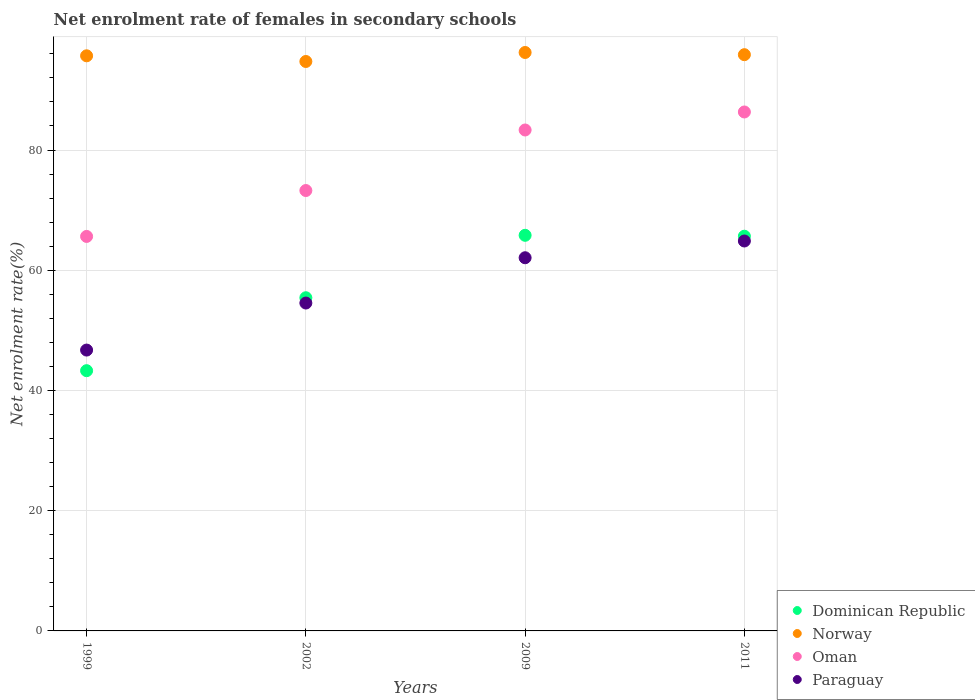How many different coloured dotlines are there?
Offer a terse response. 4. Is the number of dotlines equal to the number of legend labels?
Keep it short and to the point. Yes. What is the net enrolment rate of females in secondary schools in Dominican Republic in 2009?
Your answer should be very brief. 65.81. Across all years, what is the maximum net enrolment rate of females in secondary schools in Norway?
Keep it short and to the point. 96.23. Across all years, what is the minimum net enrolment rate of females in secondary schools in Paraguay?
Offer a very short reply. 46.72. In which year was the net enrolment rate of females in secondary schools in Paraguay maximum?
Make the answer very short. 2011. What is the total net enrolment rate of females in secondary schools in Dominican Republic in the graph?
Keep it short and to the point. 230.2. What is the difference between the net enrolment rate of females in secondary schools in Norway in 1999 and that in 2011?
Your answer should be compact. -0.19. What is the difference between the net enrolment rate of females in secondary schools in Oman in 1999 and the net enrolment rate of females in secondary schools in Paraguay in 2009?
Make the answer very short. 3.55. What is the average net enrolment rate of females in secondary schools in Paraguay per year?
Your response must be concise. 57.05. In the year 2002, what is the difference between the net enrolment rate of females in secondary schools in Dominican Republic and net enrolment rate of females in secondary schools in Paraguay?
Your response must be concise. 0.88. In how many years, is the net enrolment rate of females in secondary schools in Paraguay greater than 16 %?
Provide a succinct answer. 4. What is the ratio of the net enrolment rate of females in secondary schools in Paraguay in 1999 to that in 2002?
Give a very brief answer. 0.86. Is the net enrolment rate of females in secondary schools in Dominican Republic in 1999 less than that in 2011?
Your response must be concise. Yes. What is the difference between the highest and the second highest net enrolment rate of females in secondary schools in Paraguay?
Give a very brief answer. 2.79. What is the difference between the highest and the lowest net enrolment rate of females in secondary schools in Dominican Republic?
Offer a very short reply. 22.52. In how many years, is the net enrolment rate of females in secondary schools in Dominican Republic greater than the average net enrolment rate of females in secondary schools in Dominican Republic taken over all years?
Provide a short and direct response. 2. Is it the case that in every year, the sum of the net enrolment rate of females in secondary schools in Oman and net enrolment rate of females in secondary schools in Paraguay  is greater than the net enrolment rate of females in secondary schools in Dominican Republic?
Your answer should be compact. Yes. Does the net enrolment rate of females in secondary schools in Oman monotonically increase over the years?
Make the answer very short. Yes. Is the net enrolment rate of females in secondary schools in Oman strictly greater than the net enrolment rate of females in secondary schools in Norway over the years?
Ensure brevity in your answer.  No. How many dotlines are there?
Give a very brief answer. 4. How many years are there in the graph?
Offer a terse response. 4. What is the difference between two consecutive major ticks on the Y-axis?
Your answer should be compact. 20. Where does the legend appear in the graph?
Ensure brevity in your answer.  Bottom right. What is the title of the graph?
Make the answer very short. Net enrolment rate of females in secondary schools. What is the label or title of the Y-axis?
Offer a very short reply. Net enrolment rate(%). What is the Net enrolment rate(%) of Dominican Republic in 1999?
Offer a terse response. 43.29. What is the Net enrolment rate(%) of Norway in 1999?
Your answer should be very brief. 95.68. What is the Net enrolment rate(%) in Oman in 1999?
Provide a succinct answer. 65.63. What is the Net enrolment rate(%) in Paraguay in 1999?
Keep it short and to the point. 46.72. What is the Net enrolment rate(%) in Dominican Republic in 2002?
Your answer should be very brief. 55.43. What is the Net enrolment rate(%) of Norway in 2002?
Your answer should be very brief. 94.73. What is the Net enrolment rate(%) of Oman in 2002?
Your answer should be very brief. 73.26. What is the Net enrolment rate(%) in Paraguay in 2002?
Provide a short and direct response. 54.55. What is the Net enrolment rate(%) of Dominican Republic in 2009?
Your response must be concise. 65.81. What is the Net enrolment rate(%) in Norway in 2009?
Provide a short and direct response. 96.23. What is the Net enrolment rate(%) of Oman in 2009?
Your response must be concise. 83.33. What is the Net enrolment rate(%) in Paraguay in 2009?
Your response must be concise. 62.08. What is the Net enrolment rate(%) in Dominican Republic in 2011?
Offer a very short reply. 65.66. What is the Net enrolment rate(%) in Norway in 2011?
Offer a terse response. 95.86. What is the Net enrolment rate(%) in Oman in 2011?
Ensure brevity in your answer.  86.33. What is the Net enrolment rate(%) in Paraguay in 2011?
Offer a terse response. 64.87. Across all years, what is the maximum Net enrolment rate(%) of Dominican Republic?
Provide a succinct answer. 65.81. Across all years, what is the maximum Net enrolment rate(%) in Norway?
Keep it short and to the point. 96.23. Across all years, what is the maximum Net enrolment rate(%) of Oman?
Ensure brevity in your answer.  86.33. Across all years, what is the maximum Net enrolment rate(%) of Paraguay?
Offer a terse response. 64.87. Across all years, what is the minimum Net enrolment rate(%) in Dominican Republic?
Give a very brief answer. 43.29. Across all years, what is the minimum Net enrolment rate(%) of Norway?
Give a very brief answer. 94.73. Across all years, what is the minimum Net enrolment rate(%) of Oman?
Your answer should be very brief. 65.63. Across all years, what is the minimum Net enrolment rate(%) in Paraguay?
Your response must be concise. 46.72. What is the total Net enrolment rate(%) of Dominican Republic in the graph?
Make the answer very short. 230.2. What is the total Net enrolment rate(%) of Norway in the graph?
Your answer should be very brief. 382.49. What is the total Net enrolment rate(%) of Oman in the graph?
Make the answer very short. 308.55. What is the total Net enrolment rate(%) in Paraguay in the graph?
Your answer should be compact. 228.22. What is the difference between the Net enrolment rate(%) in Dominican Republic in 1999 and that in 2002?
Provide a succinct answer. -12.13. What is the difference between the Net enrolment rate(%) in Norway in 1999 and that in 2002?
Ensure brevity in your answer.  0.95. What is the difference between the Net enrolment rate(%) in Oman in 1999 and that in 2002?
Your answer should be very brief. -7.64. What is the difference between the Net enrolment rate(%) in Paraguay in 1999 and that in 2002?
Ensure brevity in your answer.  -7.82. What is the difference between the Net enrolment rate(%) of Dominican Republic in 1999 and that in 2009?
Your answer should be compact. -22.52. What is the difference between the Net enrolment rate(%) of Norway in 1999 and that in 2009?
Make the answer very short. -0.55. What is the difference between the Net enrolment rate(%) in Oman in 1999 and that in 2009?
Offer a very short reply. -17.71. What is the difference between the Net enrolment rate(%) of Paraguay in 1999 and that in 2009?
Ensure brevity in your answer.  -15.36. What is the difference between the Net enrolment rate(%) of Dominican Republic in 1999 and that in 2011?
Give a very brief answer. -22.37. What is the difference between the Net enrolment rate(%) in Norway in 1999 and that in 2011?
Ensure brevity in your answer.  -0.19. What is the difference between the Net enrolment rate(%) in Oman in 1999 and that in 2011?
Provide a short and direct response. -20.7. What is the difference between the Net enrolment rate(%) of Paraguay in 1999 and that in 2011?
Offer a very short reply. -18.15. What is the difference between the Net enrolment rate(%) in Dominican Republic in 2002 and that in 2009?
Offer a very short reply. -10.39. What is the difference between the Net enrolment rate(%) in Norway in 2002 and that in 2009?
Keep it short and to the point. -1.5. What is the difference between the Net enrolment rate(%) in Oman in 2002 and that in 2009?
Your answer should be compact. -10.07. What is the difference between the Net enrolment rate(%) in Paraguay in 2002 and that in 2009?
Offer a terse response. -7.53. What is the difference between the Net enrolment rate(%) of Dominican Republic in 2002 and that in 2011?
Offer a very short reply. -10.23. What is the difference between the Net enrolment rate(%) of Norway in 2002 and that in 2011?
Your answer should be very brief. -1.13. What is the difference between the Net enrolment rate(%) in Oman in 2002 and that in 2011?
Give a very brief answer. -13.07. What is the difference between the Net enrolment rate(%) of Paraguay in 2002 and that in 2011?
Your response must be concise. -10.32. What is the difference between the Net enrolment rate(%) of Dominican Republic in 2009 and that in 2011?
Ensure brevity in your answer.  0.15. What is the difference between the Net enrolment rate(%) in Norway in 2009 and that in 2011?
Offer a very short reply. 0.37. What is the difference between the Net enrolment rate(%) of Oman in 2009 and that in 2011?
Give a very brief answer. -3. What is the difference between the Net enrolment rate(%) in Paraguay in 2009 and that in 2011?
Your answer should be very brief. -2.79. What is the difference between the Net enrolment rate(%) in Dominican Republic in 1999 and the Net enrolment rate(%) in Norway in 2002?
Your answer should be compact. -51.44. What is the difference between the Net enrolment rate(%) in Dominican Republic in 1999 and the Net enrolment rate(%) in Oman in 2002?
Offer a terse response. -29.97. What is the difference between the Net enrolment rate(%) in Dominican Republic in 1999 and the Net enrolment rate(%) in Paraguay in 2002?
Your answer should be very brief. -11.25. What is the difference between the Net enrolment rate(%) of Norway in 1999 and the Net enrolment rate(%) of Oman in 2002?
Your answer should be very brief. 22.41. What is the difference between the Net enrolment rate(%) of Norway in 1999 and the Net enrolment rate(%) of Paraguay in 2002?
Provide a short and direct response. 41.13. What is the difference between the Net enrolment rate(%) of Oman in 1999 and the Net enrolment rate(%) of Paraguay in 2002?
Ensure brevity in your answer.  11.08. What is the difference between the Net enrolment rate(%) in Dominican Republic in 1999 and the Net enrolment rate(%) in Norway in 2009?
Give a very brief answer. -52.93. What is the difference between the Net enrolment rate(%) in Dominican Republic in 1999 and the Net enrolment rate(%) in Oman in 2009?
Provide a succinct answer. -40.04. What is the difference between the Net enrolment rate(%) of Dominican Republic in 1999 and the Net enrolment rate(%) of Paraguay in 2009?
Provide a short and direct response. -18.79. What is the difference between the Net enrolment rate(%) of Norway in 1999 and the Net enrolment rate(%) of Oman in 2009?
Ensure brevity in your answer.  12.34. What is the difference between the Net enrolment rate(%) of Norway in 1999 and the Net enrolment rate(%) of Paraguay in 2009?
Your answer should be compact. 33.6. What is the difference between the Net enrolment rate(%) in Oman in 1999 and the Net enrolment rate(%) in Paraguay in 2009?
Provide a succinct answer. 3.55. What is the difference between the Net enrolment rate(%) in Dominican Republic in 1999 and the Net enrolment rate(%) in Norway in 2011?
Make the answer very short. -52.57. What is the difference between the Net enrolment rate(%) of Dominican Republic in 1999 and the Net enrolment rate(%) of Oman in 2011?
Your answer should be compact. -43.04. What is the difference between the Net enrolment rate(%) of Dominican Republic in 1999 and the Net enrolment rate(%) of Paraguay in 2011?
Offer a terse response. -21.57. What is the difference between the Net enrolment rate(%) of Norway in 1999 and the Net enrolment rate(%) of Oman in 2011?
Make the answer very short. 9.35. What is the difference between the Net enrolment rate(%) in Norway in 1999 and the Net enrolment rate(%) in Paraguay in 2011?
Your response must be concise. 30.81. What is the difference between the Net enrolment rate(%) in Oman in 1999 and the Net enrolment rate(%) in Paraguay in 2011?
Your response must be concise. 0.76. What is the difference between the Net enrolment rate(%) of Dominican Republic in 2002 and the Net enrolment rate(%) of Norway in 2009?
Provide a succinct answer. -40.8. What is the difference between the Net enrolment rate(%) of Dominican Republic in 2002 and the Net enrolment rate(%) of Oman in 2009?
Give a very brief answer. -27.91. What is the difference between the Net enrolment rate(%) of Dominican Republic in 2002 and the Net enrolment rate(%) of Paraguay in 2009?
Offer a terse response. -6.65. What is the difference between the Net enrolment rate(%) in Norway in 2002 and the Net enrolment rate(%) in Oman in 2009?
Make the answer very short. 11.4. What is the difference between the Net enrolment rate(%) in Norway in 2002 and the Net enrolment rate(%) in Paraguay in 2009?
Your answer should be compact. 32.65. What is the difference between the Net enrolment rate(%) of Oman in 2002 and the Net enrolment rate(%) of Paraguay in 2009?
Your answer should be compact. 11.18. What is the difference between the Net enrolment rate(%) in Dominican Republic in 2002 and the Net enrolment rate(%) in Norway in 2011?
Your answer should be compact. -40.43. What is the difference between the Net enrolment rate(%) of Dominican Republic in 2002 and the Net enrolment rate(%) of Oman in 2011?
Your answer should be very brief. -30.9. What is the difference between the Net enrolment rate(%) of Dominican Republic in 2002 and the Net enrolment rate(%) of Paraguay in 2011?
Give a very brief answer. -9.44. What is the difference between the Net enrolment rate(%) of Norway in 2002 and the Net enrolment rate(%) of Oman in 2011?
Your answer should be very brief. 8.4. What is the difference between the Net enrolment rate(%) of Norway in 2002 and the Net enrolment rate(%) of Paraguay in 2011?
Provide a short and direct response. 29.86. What is the difference between the Net enrolment rate(%) in Oman in 2002 and the Net enrolment rate(%) in Paraguay in 2011?
Ensure brevity in your answer.  8.4. What is the difference between the Net enrolment rate(%) in Dominican Republic in 2009 and the Net enrolment rate(%) in Norway in 2011?
Your response must be concise. -30.05. What is the difference between the Net enrolment rate(%) in Dominican Republic in 2009 and the Net enrolment rate(%) in Oman in 2011?
Offer a very short reply. -20.52. What is the difference between the Net enrolment rate(%) in Dominican Republic in 2009 and the Net enrolment rate(%) in Paraguay in 2011?
Ensure brevity in your answer.  0.95. What is the difference between the Net enrolment rate(%) of Norway in 2009 and the Net enrolment rate(%) of Oman in 2011?
Your response must be concise. 9.9. What is the difference between the Net enrolment rate(%) of Norway in 2009 and the Net enrolment rate(%) of Paraguay in 2011?
Provide a short and direct response. 31.36. What is the difference between the Net enrolment rate(%) of Oman in 2009 and the Net enrolment rate(%) of Paraguay in 2011?
Provide a short and direct response. 18.47. What is the average Net enrolment rate(%) in Dominican Republic per year?
Offer a very short reply. 57.55. What is the average Net enrolment rate(%) in Norway per year?
Your answer should be very brief. 95.62. What is the average Net enrolment rate(%) of Oman per year?
Your answer should be compact. 77.14. What is the average Net enrolment rate(%) in Paraguay per year?
Make the answer very short. 57.05. In the year 1999, what is the difference between the Net enrolment rate(%) of Dominican Republic and Net enrolment rate(%) of Norway?
Your response must be concise. -52.38. In the year 1999, what is the difference between the Net enrolment rate(%) of Dominican Republic and Net enrolment rate(%) of Oman?
Make the answer very short. -22.33. In the year 1999, what is the difference between the Net enrolment rate(%) in Dominican Republic and Net enrolment rate(%) in Paraguay?
Your response must be concise. -3.43. In the year 1999, what is the difference between the Net enrolment rate(%) of Norway and Net enrolment rate(%) of Oman?
Offer a terse response. 30.05. In the year 1999, what is the difference between the Net enrolment rate(%) of Norway and Net enrolment rate(%) of Paraguay?
Offer a terse response. 48.95. In the year 1999, what is the difference between the Net enrolment rate(%) in Oman and Net enrolment rate(%) in Paraguay?
Offer a terse response. 18.91. In the year 2002, what is the difference between the Net enrolment rate(%) of Dominican Republic and Net enrolment rate(%) of Norway?
Your answer should be compact. -39.3. In the year 2002, what is the difference between the Net enrolment rate(%) of Dominican Republic and Net enrolment rate(%) of Oman?
Offer a very short reply. -17.84. In the year 2002, what is the difference between the Net enrolment rate(%) of Dominican Republic and Net enrolment rate(%) of Paraguay?
Offer a very short reply. 0.88. In the year 2002, what is the difference between the Net enrolment rate(%) in Norway and Net enrolment rate(%) in Oman?
Keep it short and to the point. 21.47. In the year 2002, what is the difference between the Net enrolment rate(%) of Norway and Net enrolment rate(%) of Paraguay?
Give a very brief answer. 40.18. In the year 2002, what is the difference between the Net enrolment rate(%) in Oman and Net enrolment rate(%) in Paraguay?
Make the answer very short. 18.72. In the year 2009, what is the difference between the Net enrolment rate(%) in Dominican Republic and Net enrolment rate(%) in Norway?
Provide a short and direct response. -30.41. In the year 2009, what is the difference between the Net enrolment rate(%) of Dominican Republic and Net enrolment rate(%) of Oman?
Ensure brevity in your answer.  -17.52. In the year 2009, what is the difference between the Net enrolment rate(%) in Dominican Republic and Net enrolment rate(%) in Paraguay?
Your answer should be very brief. 3.73. In the year 2009, what is the difference between the Net enrolment rate(%) of Norway and Net enrolment rate(%) of Oman?
Keep it short and to the point. 12.89. In the year 2009, what is the difference between the Net enrolment rate(%) in Norway and Net enrolment rate(%) in Paraguay?
Provide a succinct answer. 34.15. In the year 2009, what is the difference between the Net enrolment rate(%) in Oman and Net enrolment rate(%) in Paraguay?
Give a very brief answer. 21.25. In the year 2011, what is the difference between the Net enrolment rate(%) of Dominican Republic and Net enrolment rate(%) of Norway?
Give a very brief answer. -30.2. In the year 2011, what is the difference between the Net enrolment rate(%) in Dominican Republic and Net enrolment rate(%) in Oman?
Give a very brief answer. -20.67. In the year 2011, what is the difference between the Net enrolment rate(%) in Dominican Republic and Net enrolment rate(%) in Paraguay?
Keep it short and to the point. 0.79. In the year 2011, what is the difference between the Net enrolment rate(%) in Norway and Net enrolment rate(%) in Oman?
Provide a short and direct response. 9.53. In the year 2011, what is the difference between the Net enrolment rate(%) in Norway and Net enrolment rate(%) in Paraguay?
Give a very brief answer. 30.99. In the year 2011, what is the difference between the Net enrolment rate(%) of Oman and Net enrolment rate(%) of Paraguay?
Make the answer very short. 21.46. What is the ratio of the Net enrolment rate(%) of Dominican Republic in 1999 to that in 2002?
Give a very brief answer. 0.78. What is the ratio of the Net enrolment rate(%) of Norway in 1999 to that in 2002?
Your answer should be compact. 1.01. What is the ratio of the Net enrolment rate(%) in Oman in 1999 to that in 2002?
Ensure brevity in your answer.  0.9. What is the ratio of the Net enrolment rate(%) of Paraguay in 1999 to that in 2002?
Keep it short and to the point. 0.86. What is the ratio of the Net enrolment rate(%) of Dominican Republic in 1999 to that in 2009?
Provide a short and direct response. 0.66. What is the ratio of the Net enrolment rate(%) in Oman in 1999 to that in 2009?
Offer a very short reply. 0.79. What is the ratio of the Net enrolment rate(%) in Paraguay in 1999 to that in 2009?
Make the answer very short. 0.75. What is the ratio of the Net enrolment rate(%) of Dominican Republic in 1999 to that in 2011?
Make the answer very short. 0.66. What is the ratio of the Net enrolment rate(%) of Oman in 1999 to that in 2011?
Offer a very short reply. 0.76. What is the ratio of the Net enrolment rate(%) in Paraguay in 1999 to that in 2011?
Offer a very short reply. 0.72. What is the ratio of the Net enrolment rate(%) in Dominican Republic in 2002 to that in 2009?
Offer a terse response. 0.84. What is the ratio of the Net enrolment rate(%) of Norway in 2002 to that in 2009?
Your answer should be compact. 0.98. What is the ratio of the Net enrolment rate(%) of Oman in 2002 to that in 2009?
Keep it short and to the point. 0.88. What is the ratio of the Net enrolment rate(%) in Paraguay in 2002 to that in 2009?
Your answer should be very brief. 0.88. What is the ratio of the Net enrolment rate(%) in Dominican Republic in 2002 to that in 2011?
Your answer should be very brief. 0.84. What is the ratio of the Net enrolment rate(%) of Norway in 2002 to that in 2011?
Give a very brief answer. 0.99. What is the ratio of the Net enrolment rate(%) in Oman in 2002 to that in 2011?
Offer a very short reply. 0.85. What is the ratio of the Net enrolment rate(%) in Paraguay in 2002 to that in 2011?
Make the answer very short. 0.84. What is the ratio of the Net enrolment rate(%) of Dominican Republic in 2009 to that in 2011?
Give a very brief answer. 1. What is the ratio of the Net enrolment rate(%) of Norway in 2009 to that in 2011?
Offer a very short reply. 1. What is the ratio of the Net enrolment rate(%) of Oman in 2009 to that in 2011?
Your answer should be compact. 0.97. What is the difference between the highest and the second highest Net enrolment rate(%) of Dominican Republic?
Offer a terse response. 0.15. What is the difference between the highest and the second highest Net enrolment rate(%) of Norway?
Provide a short and direct response. 0.37. What is the difference between the highest and the second highest Net enrolment rate(%) of Oman?
Keep it short and to the point. 3. What is the difference between the highest and the second highest Net enrolment rate(%) in Paraguay?
Your answer should be very brief. 2.79. What is the difference between the highest and the lowest Net enrolment rate(%) in Dominican Republic?
Provide a succinct answer. 22.52. What is the difference between the highest and the lowest Net enrolment rate(%) of Norway?
Keep it short and to the point. 1.5. What is the difference between the highest and the lowest Net enrolment rate(%) of Oman?
Offer a very short reply. 20.7. What is the difference between the highest and the lowest Net enrolment rate(%) in Paraguay?
Offer a terse response. 18.15. 